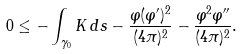<formula> <loc_0><loc_0><loc_500><loc_500>0 \leq - \int _ { \gamma _ { 0 } } K \, d s - \frac { \varphi ( \varphi ^ { \prime } ) ^ { 2 } } { ( 4 \pi ) ^ { 2 } } - \frac { \varphi ^ { 2 } \varphi ^ { \prime \prime } } { ( 4 \pi ) ^ { 2 } } .</formula> 